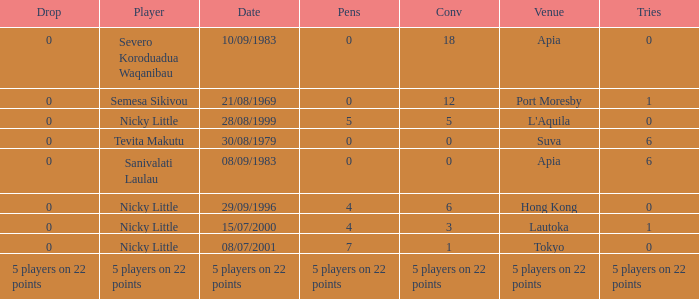How many drops did Nicky Little have in Hong Kong? 0.0. 